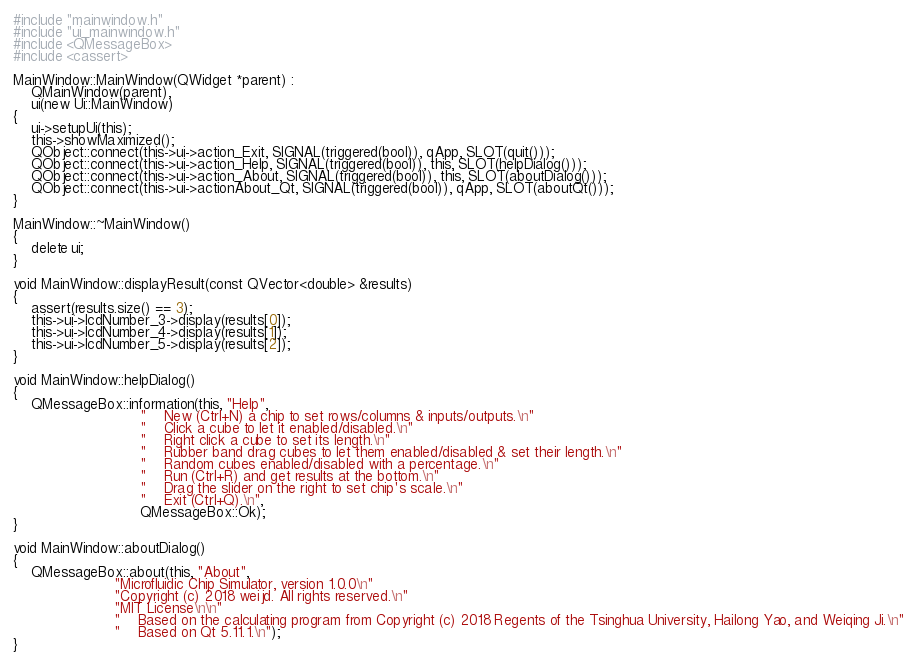<code> <loc_0><loc_0><loc_500><loc_500><_C++_>#include "mainwindow.h"
#include "ui_mainwindow.h"
#include <QMessageBox>
#include <cassert>

MainWindow::MainWindow(QWidget *parent) :
    QMainWindow(parent),
    ui(new Ui::MainWindow)
{
    ui->setupUi(this);
    this->showMaximized();
    QObject::connect(this->ui->action_Exit, SIGNAL(triggered(bool)), qApp, SLOT(quit()));
    QObject::connect(this->ui->action_Help, SIGNAL(triggered(bool)), this, SLOT(helpDialog()));
    QObject::connect(this->ui->action_About, SIGNAL(triggered(bool)), this, SLOT(aboutDialog()));
    QObject::connect(this->ui->actionAbout_Qt, SIGNAL(triggered(bool)), qApp, SLOT(aboutQt()));
}

MainWindow::~MainWindow()
{
    delete ui;
}

void MainWindow::displayResult(const QVector<double> &results)
{
    assert(results.size() == 3);
    this->ui->lcdNumber_3->display(results[0]);
    this->ui->lcdNumber_4->display(results[1]);
    this->ui->lcdNumber_5->display(results[2]);
}

void MainWindow::helpDialog()
{
    QMessageBox::information(this, "Help",
                             "    New (Ctrl+N) a chip to set rows/columns & inputs/outputs.\n"
                             "    Click a cube to let it enabled/disabled.\n"
                             "    Right click a cube to set its length.\n"
                             "    Rubber band drag cubes to let them enabled/disabled & set their length.\n"
                             "    Random cubes enabled/disabled with a percentage.\n"
                             "    Run (Ctrl+R) and get results at the bottom.\n"
                             "    Drag the slider on the right to set chip's scale.\n"
                             "    Exit (Ctrl+Q).\n",
                             QMessageBox::Ok);
}

void MainWindow::aboutDialog()
{
    QMessageBox::about(this, "About",
                       "Microfluidic Chip Simulator, version 1.0.0\n"
                       "Copyright (c) 2018 weijd. All rights reserved.\n"
                       "MIT License\n\n"
                       "    Based on the calculating program from Copyright (c) 2018 Regents of the Tsinghua University, Hailong Yao, and Weiqing Ji.\n"
                       "    Based on Qt 5.11.1.\n");
}
</code> 